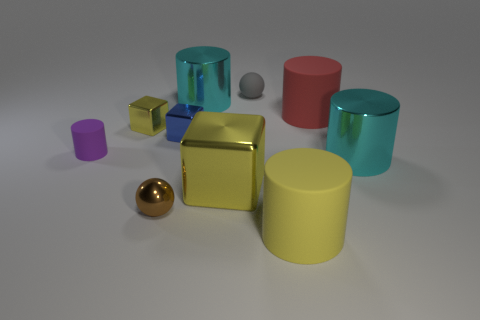There is a cylinder that is the same color as the large block; what is its size?
Your answer should be very brief. Large. There is a rubber object that is the same color as the big block; what shape is it?
Your answer should be compact. Cylinder. How many gray matte balls are the same size as the gray rubber thing?
Offer a very short reply. 0. There is a tiny yellow thing that is the same shape as the small blue metallic object; what material is it?
Ensure brevity in your answer.  Metal. What is the shape of the tiny thing that is both on the right side of the small brown metal ball and on the left side of the gray matte thing?
Your answer should be compact. Cube. There is a big cyan metallic object behind the small rubber cylinder; what is its shape?
Offer a very short reply. Cylinder. What number of small things are both to the right of the tiny purple cylinder and on the left side of the tiny gray rubber ball?
Provide a short and direct response. 3. Do the yellow cylinder and the cyan metal cylinder on the right side of the big yellow cylinder have the same size?
Offer a very short reply. Yes. There is a sphere behind the big shiny object right of the yellow matte cylinder that is on the right side of the gray matte ball; how big is it?
Your answer should be compact. Small. There is a cyan metallic cylinder behind the tiny yellow block; what is its size?
Provide a succinct answer. Large. 